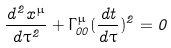Convert formula to latex. <formula><loc_0><loc_0><loc_500><loc_500>\frac { d ^ { 2 } x ^ { \mu } } { d \tau ^ { 2 } } + \Gamma ^ { \mu } _ { 0 0 } ( \frac { d t } { d \tau } ) ^ { 2 } = 0</formula> 